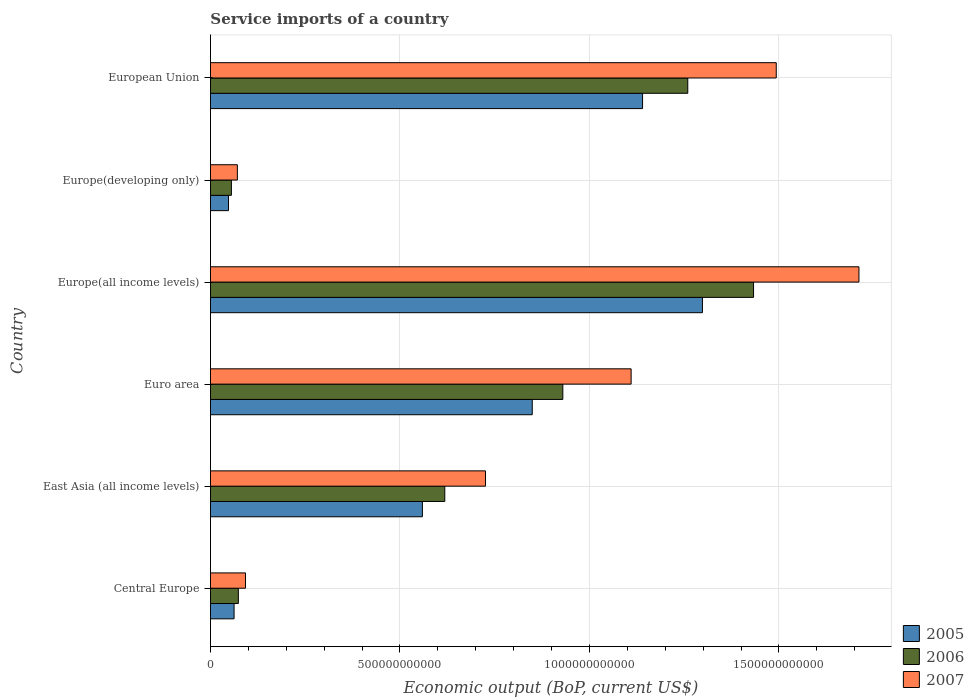How many different coloured bars are there?
Your answer should be very brief. 3. How many groups of bars are there?
Offer a very short reply. 6. Are the number of bars per tick equal to the number of legend labels?
Make the answer very short. Yes. How many bars are there on the 5th tick from the bottom?
Offer a very short reply. 3. What is the label of the 5th group of bars from the top?
Provide a succinct answer. East Asia (all income levels). In how many cases, is the number of bars for a given country not equal to the number of legend labels?
Give a very brief answer. 0. What is the service imports in 2006 in Central Europe?
Keep it short and to the point. 7.35e+1. Across all countries, what is the maximum service imports in 2006?
Your response must be concise. 1.43e+12. Across all countries, what is the minimum service imports in 2007?
Your response must be concise. 7.10e+1. In which country was the service imports in 2006 maximum?
Your answer should be compact. Europe(all income levels). In which country was the service imports in 2006 minimum?
Provide a succinct answer. Europe(developing only). What is the total service imports in 2007 in the graph?
Ensure brevity in your answer.  5.20e+12. What is the difference between the service imports in 2005 in Central Europe and that in European Union?
Provide a succinct answer. -1.08e+12. What is the difference between the service imports in 2005 in Europe(all income levels) and the service imports in 2007 in European Union?
Give a very brief answer. -1.95e+11. What is the average service imports in 2005 per country?
Your response must be concise. 6.59e+11. What is the difference between the service imports in 2006 and service imports in 2005 in Euro area?
Ensure brevity in your answer.  8.07e+1. What is the ratio of the service imports in 2005 in Central Europe to that in Europe(all income levels)?
Provide a succinct answer. 0.05. Is the service imports in 2007 in Euro area less than that in European Union?
Make the answer very short. Yes. Is the difference between the service imports in 2006 in East Asia (all income levels) and Euro area greater than the difference between the service imports in 2005 in East Asia (all income levels) and Euro area?
Offer a very short reply. No. What is the difference between the highest and the second highest service imports in 2006?
Keep it short and to the point. 1.74e+11. What is the difference between the highest and the lowest service imports in 2005?
Your response must be concise. 1.25e+12. What does the 3rd bar from the top in Europe(all income levels) represents?
Ensure brevity in your answer.  2005. How many bars are there?
Your answer should be very brief. 18. Are all the bars in the graph horizontal?
Your answer should be compact. Yes. What is the difference between two consecutive major ticks on the X-axis?
Make the answer very short. 5.00e+11. Are the values on the major ticks of X-axis written in scientific E-notation?
Make the answer very short. No. What is the title of the graph?
Offer a very short reply. Service imports of a country. What is the label or title of the X-axis?
Offer a very short reply. Economic output (BoP, current US$). What is the Economic output (BoP, current US$) in 2005 in Central Europe?
Make the answer very short. 6.23e+1. What is the Economic output (BoP, current US$) of 2006 in Central Europe?
Offer a terse response. 7.35e+1. What is the Economic output (BoP, current US$) of 2007 in Central Europe?
Keep it short and to the point. 9.24e+1. What is the Economic output (BoP, current US$) of 2005 in East Asia (all income levels)?
Offer a very short reply. 5.59e+11. What is the Economic output (BoP, current US$) in 2006 in East Asia (all income levels)?
Your response must be concise. 6.18e+11. What is the Economic output (BoP, current US$) of 2007 in East Asia (all income levels)?
Provide a succinct answer. 7.26e+11. What is the Economic output (BoP, current US$) in 2005 in Euro area?
Provide a succinct answer. 8.49e+11. What is the Economic output (BoP, current US$) of 2006 in Euro area?
Your answer should be very brief. 9.30e+11. What is the Economic output (BoP, current US$) of 2007 in Euro area?
Keep it short and to the point. 1.11e+12. What is the Economic output (BoP, current US$) in 2005 in Europe(all income levels)?
Your answer should be compact. 1.30e+12. What is the Economic output (BoP, current US$) of 2006 in Europe(all income levels)?
Your answer should be very brief. 1.43e+12. What is the Economic output (BoP, current US$) of 2007 in Europe(all income levels)?
Your answer should be compact. 1.71e+12. What is the Economic output (BoP, current US$) of 2005 in Europe(developing only)?
Offer a terse response. 4.76e+1. What is the Economic output (BoP, current US$) in 2006 in Europe(developing only)?
Make the answer very short. 5.52e+1. What is the Economic output (BoP, current US$) in 2007 in Europe(developing only)?
Keep it short and to the point. 7.10e+1. What is the Economic output (BoP, current US$) in 2005 in European Union?
Provide a short and direct response. 1.14e+12. What is the Economic output (BoP, current US$) in 2006 in European Union?
Ensure brevity in your answer.  1.26e+12. What is the Economic output (BoP, current US$) in 2007 in European Union?
Provide a succinct answer. 1.49e+12. Across all countries, what is the maximum Economic output (BoP, current US$) of 2005?
Your answer should be very brief. 1.30e+12. Across all countries, what is the maximum Economic output (BoP, current US$) of 2006?
Offer a very short reply. 1.43e+12. Across all countries, what is the maximum Economic output (BoP, current US$) in 2007?
Your answer should be compact. 1.71e+12. Across all countries, what is the minimum Economic output (BoP, current US$) of 2005?
Your answer should be compact. 4.76e+1. Across all countries, what is the minimum Economic output (BoP, current US$) in 2006?
Give a very brief answer. 5.52e+1. Across all countries, what is the minimum Economic output (BoP, current US$) in 2007?
Provide a short and direct response. 7.10e+1. What is the total Economic output (BoP, current US$) of 2005 in the graph?
Offer a terse response. 3.96e+12. What is the total Economic output (BoP, current US$) in 2006 in the graph?
Provide a succinct answer. 4.37e+12. What is the total Economic output (BoP, current US$) in 2007 in the graph?
Your response must be concise. 5.20e+12. What is the difference between the Economic output (BoP, current US$) in 2005 in Central Europe and that in East Asia (all income levels)?
Offer a very short reply. -4.97e+11. What is the difference between the Economic output (BoP, current US$) of 2006 in Central Europe and that in East Asia (all income levels)?
Offer a terse response. -5.45e+11. What is the difference between the Economic output (BoP, current US$) in 2007 in Central Europe and that in East Asia (all income levels)?
Your answer should be very brief. -6.33e+11. What is the difference between the Economic output (BoP, current US$) of 2005 in Central Europe and that in Euro area?
Ensure brevity in your answer.  -7.87e+11. What is the difference between the Economic output (BoP, current US$) of 2006 in Central Europe and that in Euro area?
Offer a terse response. -8.56e+11. What is the difference between the Economic output (BoP, current US$) in 2007 in Central Europe and that in Euro area?
Keep it short and to the point. -1.02e+12. What is the difference between the Economic output (BoP, current US$) in 2005 in Central Europe and that in Europe(all income levels)?
Your answer should be very brief. -1.24e+12. What is the difference between the Economic output (BoP, current US$) in 2006 in Central Europe and that in Europe(all income levels)?
Ensure brevity in your answer.  -1.36e+12. What is the difference between the Economic output (BoP, current US$) of 2007 in Central Europe and that in Europe(all income levels)?
Your answer should be compact. -1.62e+12. What is the difference between the Economic output (BoP, current US$) in 2005 in Central Europe and that in Europe(developing only)?
Offer a very short reply. 1.47e+1. What is the difference between the Economic output (BoP, current US$) of 2006 in Central Europe and that in Europe(developing only)?
Your response must be concise. 1.84e+1. What is the difference between the Economic output (BoP, current US$) of 2007 in Central Europe and that in Europe(developing only)?
Offer a terse response. 2.14e+1. What is the difference between the Economic output (BoP, current US$) of 2005 in Central Europe and that in European Union?
Provide a short and direct response. -1.08e+12. What is the difference between the Economic output (BoP, current US$) in 2006 in Central Europe and that in European Union?
Offer a very short reply. -1.19e+12. What is the difference between the Economic output (BoP, current US$) of 2007 in Central Europe and that in European Union?
Provide a succinct answer. -1.40e+12. What is the difference between the Economic output (BoP, current US$) in 2005 in East Asia (all income levels) and that in Euro area?
Make the answer very short. -2.90e+11. What is the difference between the Economic output (BoP, current US$) of 2006 in East Asia (all income levels) and that in Euro area?
Give a very brief answer. -3.11e+11. What is the difference between the Economic output (BoP, current US$) in 2007 in East Asia (all income levels) and that in Euro area?
Provide a succinct answer. -3.84e+11. What is the difference between the Economic output (BoP, current US$) of 2005 in East Asia (all income levels) and that in Europe(all income levels)?
Your answer should be very brief. -7.39e+11. What is the difference between the Economic output (BoP, current US$) in 2006 in East Asia (all income levels) and that in Europe(all income levels)?
Ensure brevity in your answer.  -8.15e+11. What is the difference between the Economic output (BoP, current US$) of 2007 in East Asia (all income levels) and that in Europe(all income levels)?
Keep it short and to the point. -9.85e+11. What is the difference between the Economic output (BoP, current US$) of 2005 in East Asia (all income levels) and that in Europe(developing only)?
Your response must be concise. 5.12e+11. What is the difference between the Economic output (BoP, current US$) of 2006 in East Asia (all income levels) and that in Europe(developing only)?
Provide a succinct answer. 5.63e+11. What is the difference between the Economic output (BoP, current US$) in 2007 in East Asia (all income levels) and that in Europe(developing only)?
Your response must be concise. 6.55e+11. What is the difference between the Economic output (BoP, current US$) in 2005 in East Asia (all income levels) and that in European Union?
Ensure brevity in your answer.  -5.81e+11. What is the difference between the Economic output (BoP, current US$) of 2006 in East Asia (all income levels) and that in European Union?
Provide a short and direct response. -6.41e+11. What is the difference between the Economic output (BoP, current US$) in 2007 in East Asia (all income levels) and that in European Union?
Ensure brevity in your answer.  -7.67e+11. What is the difference between the Economic output (BoP, current US$) of 2005 in Euro area and that in Europe(all income levels)?
Your response must be concise. -4.49e+11. What is the difference between the Economic output (BoP, current US$) of 2006 in Euro area and that in Europe(all income levels)?
Your response must be concise. -5.03e+11. What is the difference between the Economic output (BoP, current US$) in 2007 in Euro area and that in Europe(all income levels)?
Make the answer very short. -6.01e+11. What is the difference between the Economic output (BoP, current US$) in 2005 in Euro area and that in Europe(developing only)?
Give a very brief answer. 8.02e+11. What is the difference between the Economic output (BoP, current US$) of 2006 in Euro area and that in Europe(developing only)?
Your answer should be compact. 8.75e+11. What is the difference between the Economic output (BoP, current US$) of 2007 in Euro area and that in Europe(developing only)?
Your answer should be compact. 1.04e+12. What is the difference between the Economic output (BoP, current US$) in 2005 in Euro area and that in European Union?
Your answer should be compact. -2.91e+11. What is the difference between the Economic output (BoP, current US$) in 2006 in Euro area and that in European Union?
Offer a very short reply. -3.30e+11. What is the difference between the Economic output (BoP, current US$) of 2007 in Euro area and that in European Union?
Make the answer very short. -3.83e+11. What is the difference between the Economic output (BoP, current US$) of 2005 in Europe(all income levels) and that in Europe(developing only)?
Offer a very short reply. 1.25e+12. What is the difference between the Economic output (BoP, current US$) of 2006 in Europe(all income levels) and that in Europe(developing only)?
Make the answer very short. 1.38e+12. What is the difference between the Economic output (BoP, current US$) in 2007 in Europe(all income levels) and that in Europe(developing only)?
Give a very brief answer. 1.64e+12. What is the difference between the Economic output (BoP, current US$) in 2005 in Europe(all income levels) and that in European Union?
Keep it short and to the point. 1.58e+11. What is the difference between the Economic output (BoP, current US$) of 2006 in Europe(all income levels) and that in European Union?
Offer a very short reply. 1.74e+11. What is the difference between the Economic output (BoP, current US$) in 2007 in Europe(all income levels) and that in European Union?
Give a very brief answer. 2.18e+11. What is the difference between the Economic output (BoP, current US$) in 2005 in Europe(developing only) and that in European Union?
Keep it short and to the point. -1.09e+12. What is the difference between the Economic output (BoP, current US$) of 2006 in Europe(developing only) and that in European Union?
Make the answer very short. -1.20e+12. What is the difference between the Economic output (BoP, current US$) of 2007 in Europe(developing only) and that in European Union?
Offer a terse response. -1.42e+12. What is the difference between the Economic output (BoP, current US$) in 2005 in Central Europe and the Economic output (BoP, current US$) in 2006 in East Asia (all income levels)?
Your answer should be compact. -5.56e+11. What is the difference between the Economic output (BoP, current US$) in 2005 in Central Europe and the Economic output (BoP, current US$) in 2007 in East Asia (all income levels)?
Make the answer very short. -6.63e+11. What is the difference between the Economic output (BoP, current US$) of 2006 in Central Europe and the Economic output (BoP, current US$) of 2007 in East Asia (all income levels)?
Provide a short and direct response. -6.52e+11. What is the difference between the Economic output (BoP, current US$) in 2005 in Central Europe and the Economic output (BoP, current US$) in 2006 in Euro area?
Provide a short and direct response. -8.68e+11. What is the difference between the Economic output (BoP, current US$) in 2005 in Central Europe and the Economic output (BoP, current US$) in 2007 in Euro area?
Your answer should be very brief. -1.05e+12. What is the difference between the Economic output (BoP, current US$) of 2006 in Central Europe and the Economic output (BoP, current US$) of 2007 in Euro area?
Your response must be concise. -1.04e+12. What is the difference between the Economic output (BoP, current US$) in 2005 in Central Europe and the Economic output (BoP, current US$) in 2006 in Europe(all income levels)?
Provide a short and direct response. -1.37e+12. What is the difference between the Economic output (BoP, current US$) in 2005 in Central Europe and the Economic output (BoP, current US$) in 2007 in Europe(all income levels)?
Offer a very short reply. -1.65e+12. What is the difference between the Economic output (BoP, current US$) in 2006 in Central Europe and the Economic output (BoP, current US$) in 2007 in Europe(all income levels)?
Provide a succinct answer. -1.64e+12. What is the difference between the Economic output (BoP, current US$) of 2005 in Central Europe and the Economic output (BoP, current US$) of 2006 in Europe(developing only)?
Your response must be concise. 7.09e+09. What is the difference between the Economic output (BoP, current US$) in 2005 in Central Europe and the Economic output (BoP, current US$) in 2007 in Europe(developing only)?
Your response must be concise. -8.67e+09. What is the difference between the Economic output (BoP, current US$) of 2006 in Central Europe and the Economic output (BoP, current US$) of 2007 in Europe(developing only)?
Keep it short and to the point. 2.58e+09. What is the difference between the Economic output (BoP, current US$) of 2005 in Central Europe and the Economic output (BoP, current US$) of 2006 in European Union?
Provide a succinct answer. -1.20e+12. What is the difference between the Economic output (BoP, current US$) in 2005 in Central Europe and the Economic output (BoP, current US$) in 2007 in European Union?
Ensure brevity in your answer.  -1.43e+12. What is the difference between the Economic output (BoP, current US$) of 2006 in Central Europe and the Economic output (BoP, current US$) of 2007 in European Union?
Your answer should be compact. -1.42e+12. What is the difference between the Economic output (BoP, current US$) of 2005 in East Asia (all income levels) and the Economic output (BoP, current US$) of 2006 in Euro area?
Make the answer very short. -3.71e+11. What is the difference between the Economic output (BoP, current US$) in 2005 in East Asia (all income levels) and the Economic output (BoP, current US$) in 2007 in Euro area?
Give a very brief answer. -5.51e+11. What is the difference between the Economic output (BoP, current US$) of 2006 in East Asia (all income levels) and the Economic output (BoP, current US$) of 2007 in Euro area?
Your answer should be compact. -4.92e+11. What is the difference between the Economic output (BoP, current US$) in 2005 in East Asia (all income levels) and the Economic output (BoP, current US$) in 2006 in Europe(all income levels)?
Your response must be concise. -8.74e+11. What is the difference between the Economic output (BoP, current US$) in 2005 in East Asia (all income levels) and the Economic output (BoP, current US$) in 2007 in Europe(all income levels)?
Your answer should be compact. -1.15e+12. What is the difference between the Economic output (BoP, current US$) of 2006 in East Asia (all income levels) and the Economic output (BoP, current US$) of 2007 in Europe(all income levels)?
Keep it short and to the point. -1.09e+12. What is the difference between the Economic output (BoP, current US$) of 2005 in East Asia (all income levels) and the Economic output (BoP, current US$) of 2006 in Europe(developing only)?
Provide a short and direct response. 5.04e+11. What is the difference between the Economic output (BoP, current US$) of 2005 in East Asia (all income levels) and the Economic output (BoP, current US$) of 2007 in Europe(developing only)?
Provide a short and direct response. 4.88e+11. What is the difference between the Economic output (BoP, current US$) in 2006 in East Asia (all income levels) and the Economic output (BoP, current US$) in 2007 in Europe(developing only)?
Your answer should be compact. 5.47e+11. What is the difference between the Economic output (BoP, current US$) in 2005 in East Asia (all income levels) and the Economic output (BoP, current US$) in 2006 in European Union?
Keep it short and to the point. -7.00e+11. What is the difference between the Economic output (BoP, current US$) in 2005 in East Asia (all income levels) and the Economic output (BoP, current US$) in 2007 in European Union?
Ensure brevity in your answer.  -9.34e+11. What is the difference between the Economic output (BoP, current US$) of 2006 in East Asia (all income levels) and the Economic output (BoP, current US$) of 2007 in European Union?
Ensure brevity in your answer.  -8.75e+11. What is the difference between the Economic output (BoP, current US$) in 2005 in Euro area and the Economic output (BoP, current US$) in 2006 in Europe(all income levels)?
Keep it short and to the point. -5.84e+11. What is the difference between the Economic output (BoP, current US$) in 2005 in Euro area and the Economic output (BoP, current US$) in 2007 in Europe(all income levels)?
Your answer should be very brief. -8.62e+11. What is the difference between the Economic output (BoP, current US$) of 2006 in Euro area and the Economic output (BoP, current US$) of 2007 in Europe(all income levels)?
Ensure brevity in your answer.  -7.81e+11. What is the difference between the Economic output (BoP, current US$) of 2005 in Euro area and the Economic output (BoP, current US$) of 2006 in Europe(developing only)?
Provide a short and direct response. 7.94e+11. What is the difference between the Economic output (BoP, current US$) of 2005 in Euro area and the Economic output (BoP, current US$) of 2007 in Europe(developing only)?
Ensure brevity in your answer.  7.78e+11. What is the difference between the Economic output (BoP, current US$) in 2006 in Euro area and the Economic output (BoP, current US$) in 2007 in Europe(developing only)?
Offer a very short reply. 8.59e+11. What is the difference between the Economic output (BoP, current US$) in 2005 in Euro area and the Economic output (BoP, current US$) in 2006 in European Union?
Your response must be concise. -4.10e+11. What is the difference between the Economic output (BoP, current US$) of 2005 in Euro area and the Economic output (BoP, current US$) of 2007 in European Union?
Ensure brevity in your answer.  -6.44e+11. What is the difference between the Economic output (BoP, current US$) of 2006 in Euro area and the Economic output (BoP, current US$) of 2007 in European Union?
Give a very brief answer. -5.63e+11. What is the difference between the Economic output (BoP, current US$) in 2005 in Europe(all income levels) and the Economic output (BoP, current US$) in 2006 in Europe(developing only)?
Your answer should be very brief. 1.24e+12. What is the difference between the Economic output (BoP, current US$) in 2005 in Europe(all income levels) and the Economic output (BoP, current US$) in 2007 in Europe(developing only)?
Offer a very short reply. 1.23e+12. What is the difference between the Economic output (BoP, current US$) of 2006 in Europe(all income levels) and the Economic output (BoP, current US$) of 2007 in Europe(developing only)?
Keep it short and to the point. 1.36e+12. What is the difference between the Economic output (BoP, current US$) of 2005 in Europe(all income levels) and the Economic output (BoP, current US$) of 2006 in European Union?
Your answer should be very brief. 3.87e+1. What is the difference between the Economic output (BoP, current US$) in 2005 in Europe(all income levels) and the Economic output (BoP, current US$) in 2007 in European Union?
Your answer should be compact. -1.95e+11. What is the difference between the Economic output (BoP, current US$) of 2006 in Europe(all income levels) and the Economic output (BoP, current US$) of 2007 in European Union?
Provide a short and direct response. -5.99e+1. What is the difference between the Economic output (BoP, current US$) in 2005 in Europe(developing only) and the Economic output (BoP, current US$) in 2006 in European Union?
Provide a succinct answer. -1.21e+12. What is the difference between the Economic output (BoP, current US$) of 2005 in Europe(developing only) and the Economic output (BoP, current US$) of 2007 in European Union?
Your response must be concise. -1.45e+12. What is the difference between the Economic output (BoP, current US$) of 2006 in Europe(developing only) and the Economic output (BoP, current US$) of 2007 in European Union?
Provide a short and direct response. -1.44e+12. What is the average Economic output (BoP, current US$) in 2005 per country?
Your answer should be very brief. 6.59e+11. What is the average Economic output (BoP, current US$) in 2006 per country?
Provide a short and direct response. 7.28e+11. What is the average Economic output (BoP, current US$) in 2007 per country?
Give a very brief answer. 8.67e+11. What is the difference between the Economic output (BoP, current US$) in 2005 and Economic output (BoP, current US$) in 2006 in Central Europe?
Give a very brief answer. -1.13e+1. What is the difference between the Economic output (BoP, current US$) of 2005 and Economic output (BoP, current US$) of 2007 in Central Europe?
Your answer should be compact. -3.01e+1. What is the difference between the Economic output (BoP, current US$) of 2006 and Economic output (BoP, current US$) of 2007 in Central Europe?
Offer a terse response. -1.89e+1. What is the difference between the Economic output (BoP, current US$) in 2005 and Economic output (BoP, current US$) in 2006 in East Asia (all income levels)?
Provide a short and direct response. -5.91e+1. What is the difference between the Economic output (BoP, current US$) in 2005 and Economic output (BoP, current US$) in 2007 in East Asia (all income levels)?
Your answer should be compact. -1.66e+11. What is the difference between the Economic output (BoP, current US$) of 2006 and Economic output (BoP, current US$) of 2007 in East Asia (all income levels)?
Provide a succinct answer. -1.07e+11. What is the difference between the Economic output (BoP, current US$) in 2005 and Economic output (BoP, current US$) in 2006 in Euro area?
Offer a very short reply. -8.07e+1. What is the difference between the Economic output (BoP, current US$) of 2005 and Economic output (BoP, current US$) of 2007 in Euro area?
Provide a short and direct response. -2.61e+11. What is the difference between the Economic output (BoP, current US$) of 2006 and Economic output (BoP, current US$) of 2007 in Euro area?
Provide a short and direct response. -1.80e+11. What is the difference between the Economic output (BoP, current US$) of 2005 and Economic output (BoP, current US$) of 2006 in Europe(all income levels)?
Your answer should be compact. -1.35e+11. What is the difference between the Economic output (BoP, current US$) in 2005 and Economic output (BoP, current US$) in 2007 in Europe(all income levels)?
Make the answer very short. -4.13e+11. What is the difference between the Economic output (BoP, current US$) of 2006 and Economic output (BoP, current US$) of 2007 in Europe(all income levels)?
Your answer should be compact. -2.78e+11. What is the difference between the Economic output (BoP, current US$) of 2005 and Economic output (BoP, current US$) of 2006 in Europe(developing only)?
Provide a succinct answer. -7.64e+09. What is the difference between the Economic output (BoP, current US$) in 2005 and Economic output (BoP, current US$) in 2007 in Europe(developing only)?
Keep it short and to the point. -2.34e+1. What is the difference between the Economic output (BoP, current US$) in 2006 and Economic output (BoP, current US$) in 2007 in Europe(developing only)?
Offer a terse response. -1.58e+1. What is the difference between the Economic output (BoP, current US$) of 2005 and Economic output (BoP, current US$) of 2006 in European Union?
Offer a very short reply. -1.19e+11. What is the difference between the Economic output (BoP, current US$) in 2005 and Economic output (BoP, current US$) in 2007 in European Union?
Give a very brief answer. -3.53e+11. What is the difference between the Economic output (BoP, current US$) of 2006 and Economic output (BoP, current US$) of 2007 in European Union?
Offer a very short reply. -2.33e+11. What is the ratio of the Economic output (BoP, current US$) in 2005 in Central Europe to that in East Asia (all income levels)?
Offer a terse response. 0.11. What is the ratio of the Economic output (BoP, current US$) of 2006 in Central Europe to that in East Asia (all income levels)?
Provide a succinct answer. 0.12. What is the ratio of the Economic output (BoP, current US$) in 2007 in Central Europe to that in East Asia (all income levels)?
Your response must be concise. 0.13. What is the ratio of the Economic output (BoP, current US$) in 2005 in Central Europe to that in Euro area?
Offer a very short reply. 0.07. What is the ratio of the Economic output (BoP, current US$) of 2006 in Central Europe to that in Euro area?
Keep it short and to the point. 0.08. What is the ratio of the Economic output (BoP, current US$) of 2007 in Central Europe to that in Euro area?
Offer a very short reply. 0.08. What is the ratio of the Economic output (BoP, current US$) in 2005 in Central Europe to that in Europe(all income levels)?
Keep it short and to the point. 0.05. What is the ratio of the Economic output (BoP, current US$) in 2006 in Central Europe to that in Europe(all income levels)?
Ensure brevity in your answer.  0.05. What is the ratio of the Economic output (BoP, current US$) of 2007 in Central Europe to that in Europe(all income levels)?
Provide a short and direct response. 0.05. What is the ratio of the Economic output (BoP, current US$) of 2005 in Central Europe to that in Europe(developing only)?
Offer a very short reply. 1.31. What is the ratio of the Economic output (BoP, current US$) of 2006 in Central Europe to that in Europe(developing only)?
Your response must be concise. 1.33. What is the ratio of the Economic output (BoP, current US$) of 2007 in Central Europe to that in Europe(developing only)?
Provide a short and direct response. 1.3. What is the ratio of the Economic output (BoP, current US$) in 2005 in Central Europe to that in European Union?
Your answer should be compact. 0.05. What is the ratio of the Economic output (BoP, current US$) of 2006 in Central Europe to that in European Union?
Your response must be concise. 0.06. What is the ratio of the Economic output (BoP, current US$) in 2007 in Central Europe to that in European Union?
Ensure brevity in your answer.  0.06. What is the ratio of the Economic output (BoP, current US$) of 2005 in East Asia (all income levels) to that in Euro area?
Offer a very short reply. 0.66. What is the ratio of the Economic output (BoP, current US$) of 2006 in East Asia (all income levels) to that in Euro area?
Ensure brevity in your answer.  0.67. What is the ratio of the Economic output (BoP, current US$) of 2007 in East Asia (all income levels) to that in Euro area?
Your answer should be compact. 0.65. What is the ratio of the Economic output (BoP, current US$) in 2005 in East Asia (all income levels) to that in Europe(all income levels)?
Your answer should be very brief. 0.43. What is the ratio of the Economic output (BoP, current US$) of 2006 in East Asia (all income levels) to that in Europe(all income levels)?
Your answer should be compact. 0.43. What is the ratio of the Economic output (BoP, current US$) in 2007 in East Asia (all income levels) to that in Europe(all income levels)?
Keep it short and to the point. 0.42. What is the ratio of the Economic output (BoP, current US$) in 2005 in East Asia (all income levels) to that in Europe(developing only)?
Make the answer very short. 11.76. What is the ratio of the Economic output (BoP, current US$) of 2006 in East Asia (all income levels) to that in Europe(developing only)?
Offer a very short reply. 11.2. What is the ratio of the Economic output (BoP, current US$) of 2007 in East Asia (all income levels) to that in Europe(developing only)?
Ensure brevity in your answer.  10.23. What is the ratio of the Economic output (BoP, current US$) in 2005 in East Asia (all income levels) to that in European Union?
Your answer should be very brief. 0.49. What is the ratio of the Economic output (BoP, current US$) in 2006 in East Asia (all income levels) to that in European Union?
Make the answer very short. 0.49. What is the ratio of the Economic output (BoP, current US$) of 2007 in East Asia (all income levels) to that in European Union?
Your response must be concise. 0.49. What is the ratio of the Economic output (BoP, current US$) of 2005 in Euro area to that in Europe(all income levels)?
Give a very brief answer. 0.65. What is the ratio of the Economic output (BoP, current US$) in 2006 in Euro area to that in Europe(all income levels)?
Offer a very short reply. 0.65. What is the ratio of the Economic output (BoP, current US$) in 2007 in Euro area to that in Europe(all income levels)?
Provide a succinct answer. 0.65. What is the ratio of the Economic output (BoP, current US$) of 2005 in Euro area to that in Europe(developing only)?
Make the answer very short. 17.85. What is the ratio of the Economic output (BoP, current US$) in 2006 in Euro area to that in Europe(developing only)?
Provide a succinct answer. 16.85. What is the ratio of the Economic output (BoP, current US$) of 2007 in Euro area to that in Europe(developing only)?
Give a very brief answer. 15.64. What is the ratio of the Economic output (BoP, current US$) in 2005 in Euro area to that in European Union?
Make the answer very short. 0.74. What is the ratio of the Economic output (BoP, current US$) of 2006 in Euro area to that in European Union?
Ensure brevity in your answer.  0.74. What is the ratio of the Economic output (BoP, current US$) of 2007 in Euro area to that in European Union?
Keep it short and to the point. 0.74. What is the ratio of the Economic output (BoP, current US$) of 2005 in Europe(all income levels) to that in Europe(developing only)?
Keep it short and to the point. 27.3. What is the ratio of the Economic output (BoP, current US$) of 2006 in Europe(all income levels) to that in Europe(developing only)?
Provide a succinct answer. 25.96. What is the ratio of the Economic output (BoP, current US$) in 2007 in Europe(all income levels) to that in Europe(developing only)?
Your response must be concise. 24.11. What is the ratio of the Economic output (BoP, current US$) in 2005 in Europe(all income levels) to that in European Union?
Your answer should be very brief. 1.14. What is the ratio of the Economic output (BoP, current US$) in 2006 in Europe(all income levels) to that in European Union?
Your response must be concise. 1.14. What is the ratio of the Economic output (BoP, current US$) of 2007 in Europe(all income levels) to that in European Union?
Your answer should be compact. 1.15. What is the ratio of the Economic output (BoP, current US$) in 2005 in Europe(developing only) to that in European Union?
Your answer should be very brief. 0.04. What is the ratio of the Economic output (BoP, current US$) of 2006 in Europe(developing only) to that in European Union?
Your answer should be very brief. 0.04. What is the ratio of the Economic output (BoP, current US$) of 2007 in Europe(developing only) to that in European Union?
Make the answer very short. 0.05. What is the difference between the highest and the second highest Economic output (BoP, current US$) of 2005?
Ensure brevity in your answer.  1.58e+11. What is the difference between the highest and the second highest Economic output (BoP, current US$) of 2006?
Ensure brevity in your answer.  1.74e+11. What is the difference between the highest and the second highest Economic output (BoP, current US$) in 2007?
Keep it short and to the point. 2.18e+11. What is the difference between the highest and the lowest Economic output (BoP, current US$) of 2005?
Keep it short and to the point. 1.25e+12. What is the difference between the highest and the lowest Economic output (BoP, current US$) in 2006?
Make the answer very short. 1.38e+12. What is the difference between the highest and the lowest Economic output (BoP, current US$) of 2007?
Offer a very short reply. 1.64e+12. 